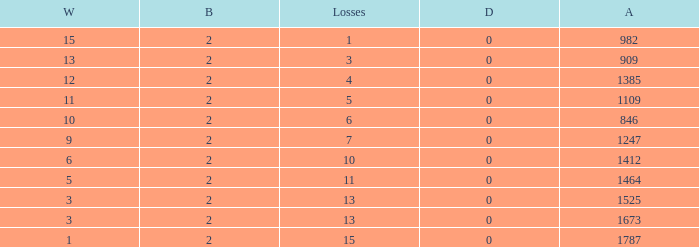What is the highest number listed under against when there were less than 3 wins and less than 15 losses? None. 